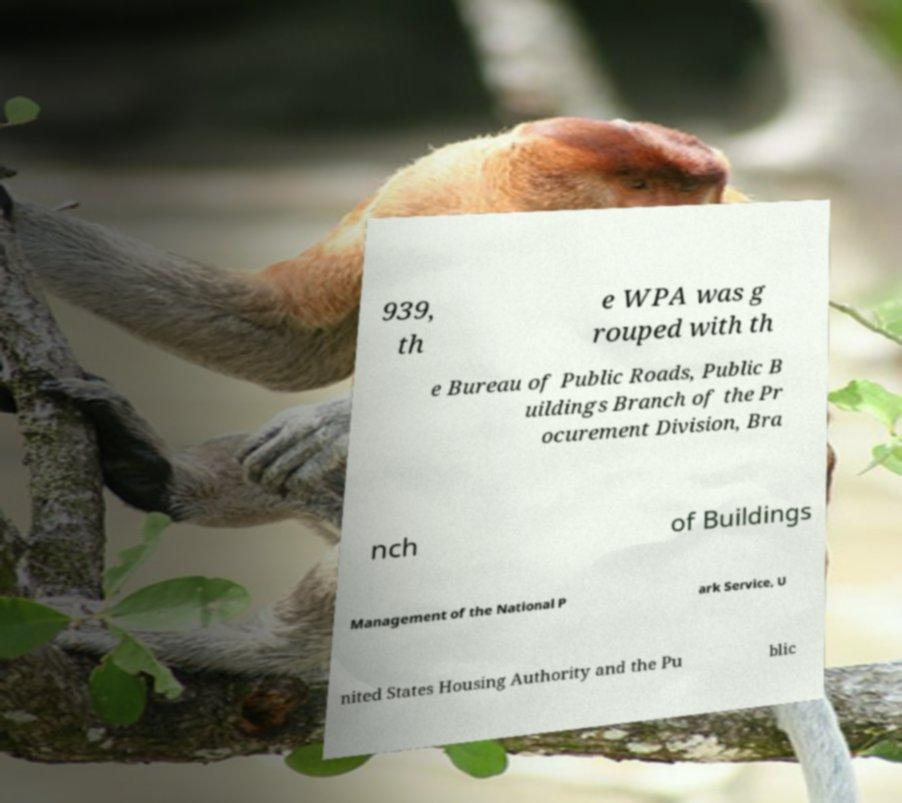Could you extract and type out the text from this image? 939, th e WPA was g rouped with th e Bureau of Public Roads, Public B uildings Branch of the Pr ocurement Division, Bra nch of Buildings Management of the National P ark Service, U nited States Housing Authority and the Pu blic 